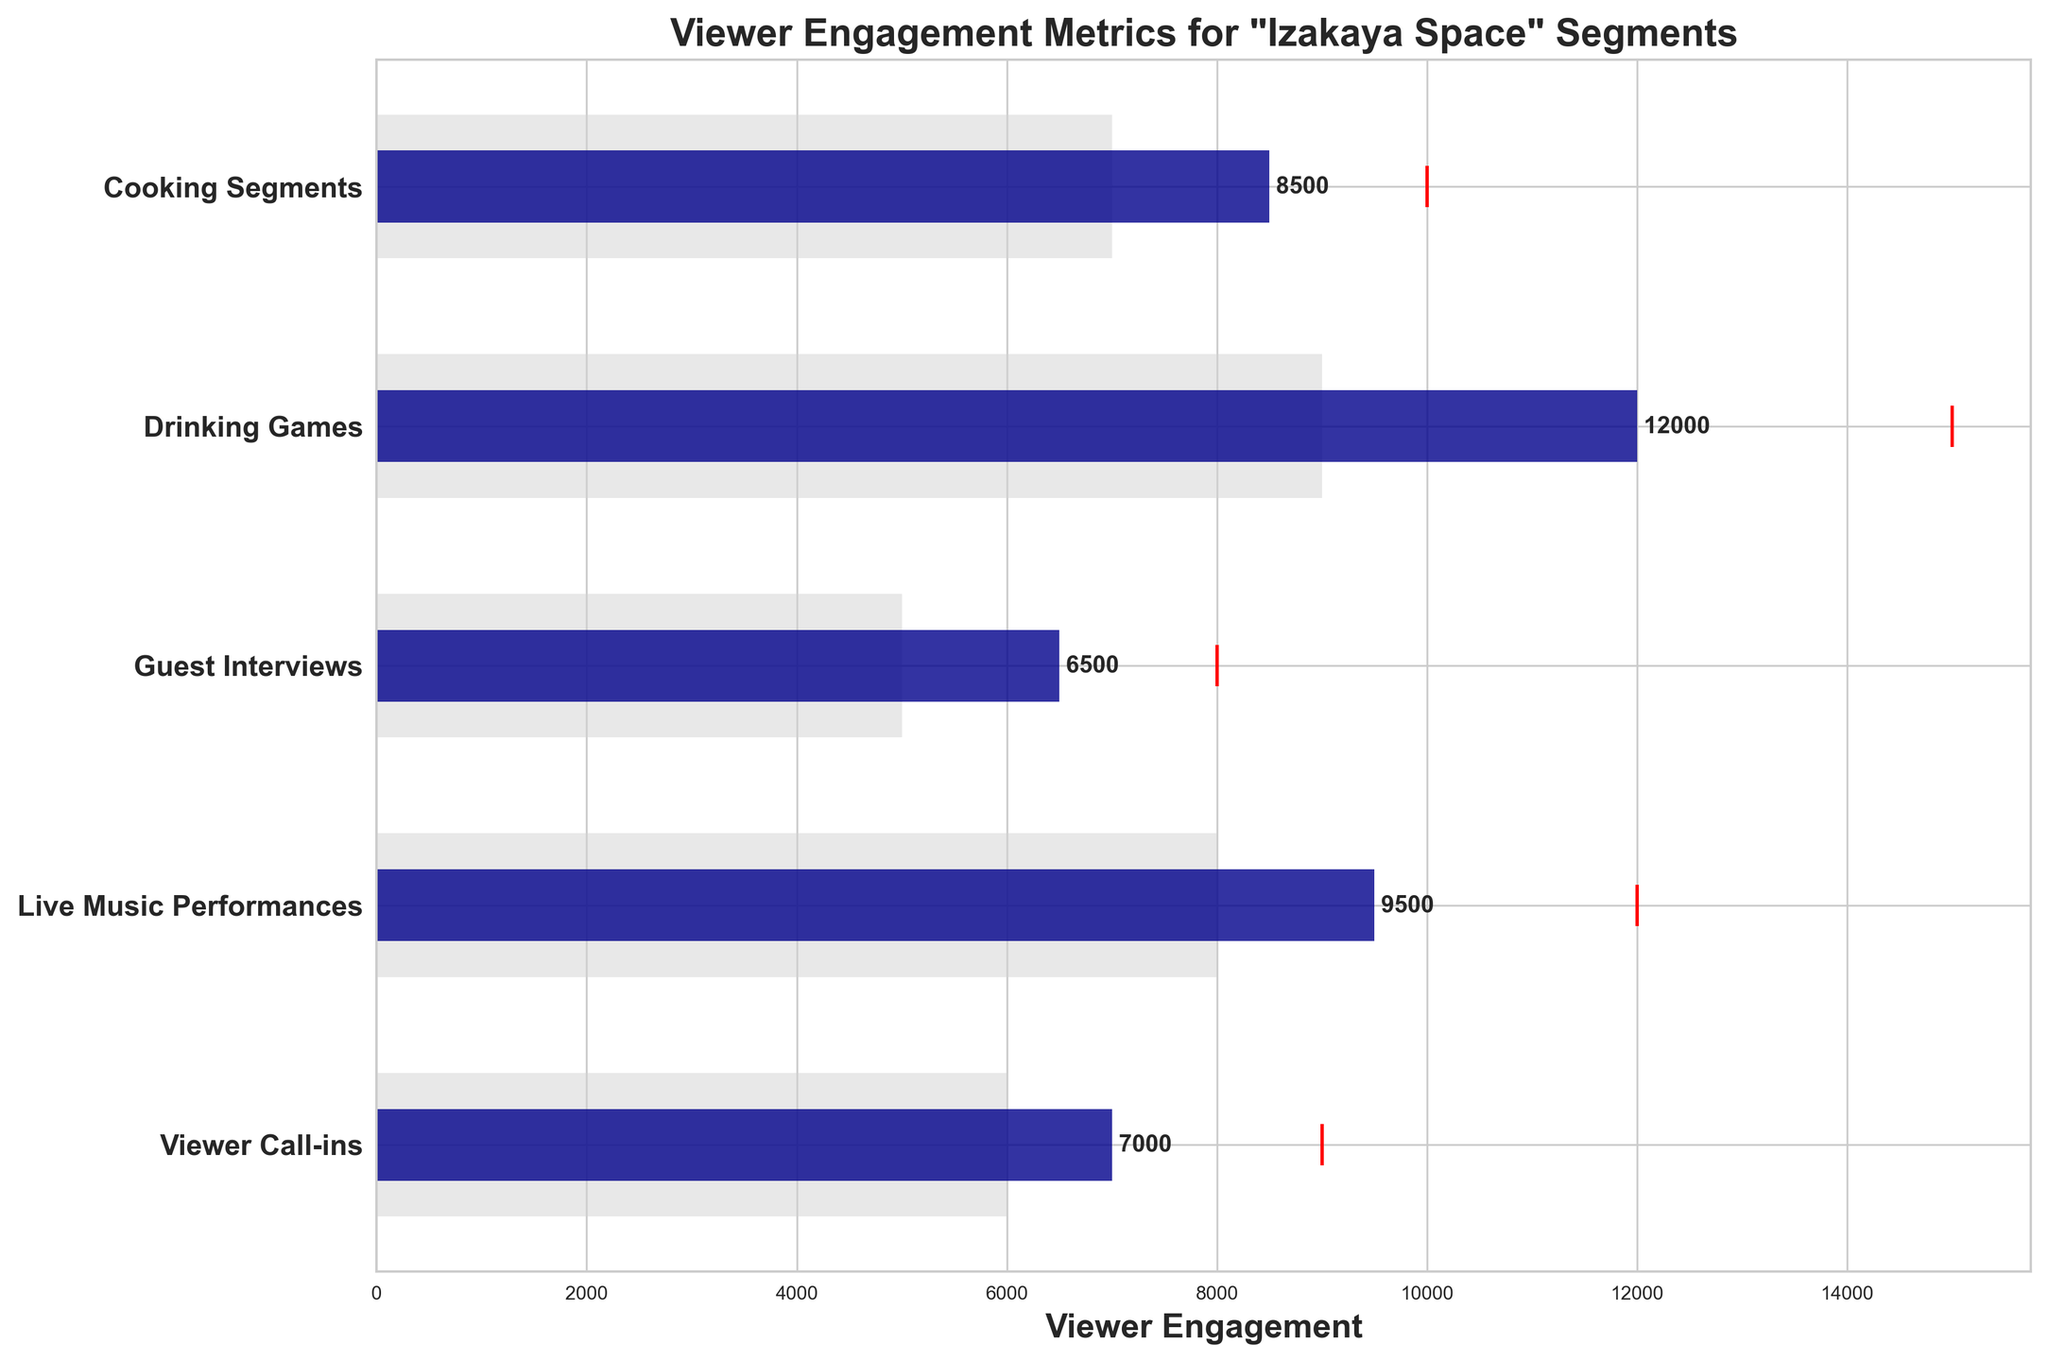What is the title of the figure? The title of the figure is typically located at the top of the plot. It provides an overview of what the plot represents. In this case, it gives the context related to viewer engagement metrics.
Answer: Viewer Engagement Metrics for "Izakaya Space" Segments What are the categories shown on the Y-axis? The Y-axis generally displays the different segments or categories being analyzed in the figure. Identifying them involves reading the labels directly from the Y-axis.
Answer: Cooking Segments, Drinking Games, Guest Interviews, Live Music Performances, Viewer Call-ins Which segment has the highest actual viewer engagement? To find this, look for the largest blue bar among the different categories. This bar represents the actual viewer engagement for each segment.
Answer: Drinking Games What color represents the comparative viewer engagement? Each color in the chart corresponds to a different type of data. The comparative viewer engagement uses a light grey color.
Answer: Light grey How many segments have their actual viewer engagement below the target? Compare the blue bars (actual) for each segment with the red markers (target). Count the segments where the blue bar height is less than the red marker's position.
Answer: 5 What is the difference in actual viewer engagement between Cooking Segments and Live Music Performances? Find the values for Cooking Segments and Live Music Performances (8500 and 9500 respectively) and calculate the difference. 9500 - 8500.
Answer: 1000 Which segment has the smallest difference between actual and target viewer engagement? For each segment calculate the difference between actual and target viewer engagements and find the smallest. The smallest difference here is in Guest Interviews.
Answer: 1500 What is the proportion of actual viewer engagement to the comparative viewer engagement in the Drinking Games segment? Divide the actual viewer engagement value by the comparative viewer engagement value for Drinking Games (12000 and 9000 respectively). 12000 / 9000
Answer: 1.33 How does the actual viewer engagement in Viewer Call-ins compare to its target engagement? Compare the blue bar height with the position of the red marker for Viewer Call-ins. The actual viewer engagement is less than the target (7000 vs. 9000).
Answer: Less than Which category's comparative engagement is closest to its target engagement? Calculate the absolute differences between comparative and target engagement values for all categories and identify the smallest difference. In this case, Live Music Performances have a comparative engagement of 8000 and a target of 12000 (a difference of 4000).
Answer: Guest Interviews 